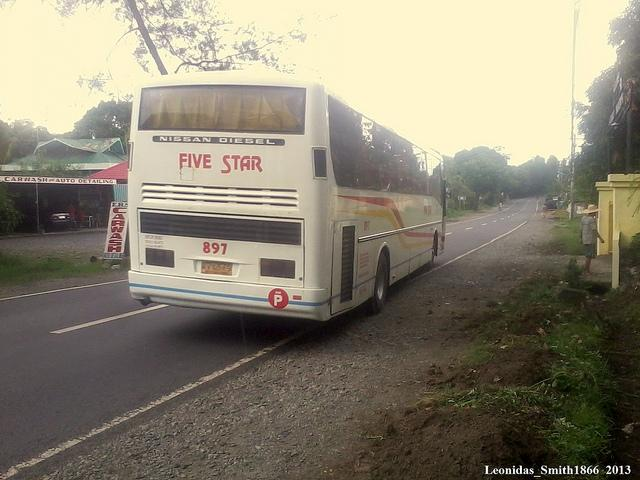The D word here refers to what? Please explain your reasoning. fuel. The d word is fuel. 